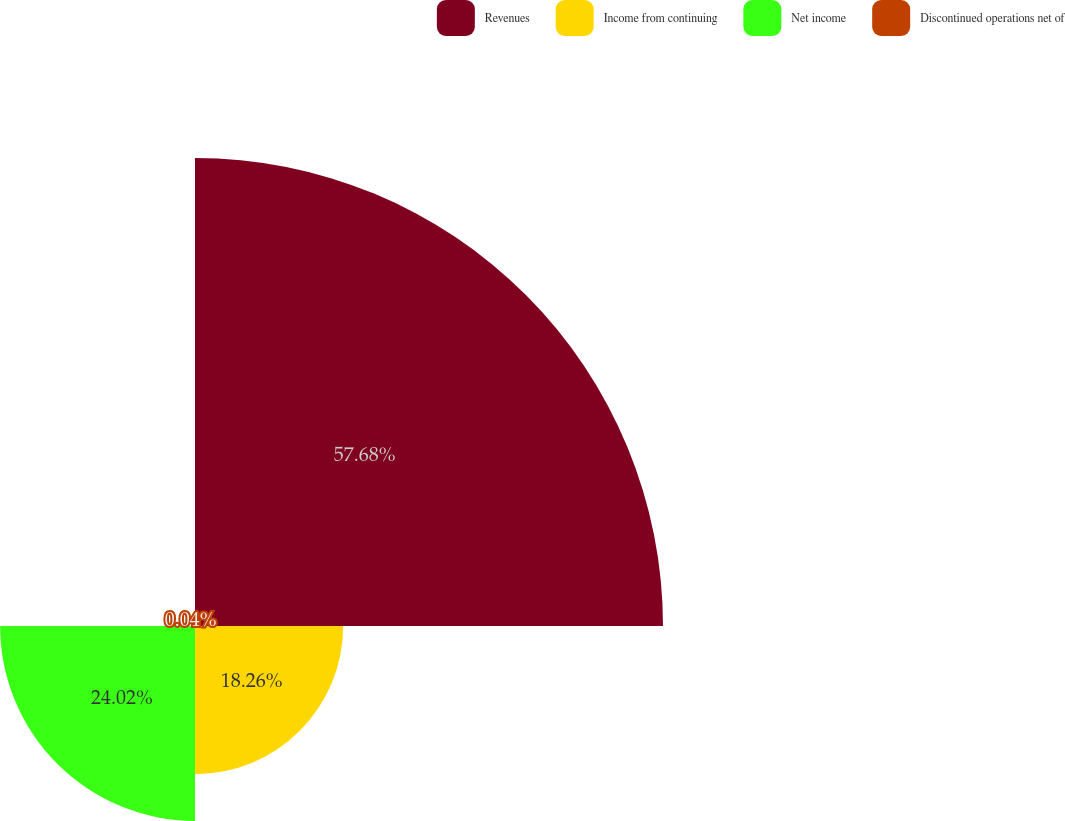<chart> <loc_0><loc_0><loc_500><loc_500><pie_chart><fcel>Revenues<fcel>Income from continuing<fcel>Net income<fcel>Discontinued operations net of<nl><fcel>57.68%<fcel>18.26%<fcel>24.02%<fcel>0.04%<nl></chart> 